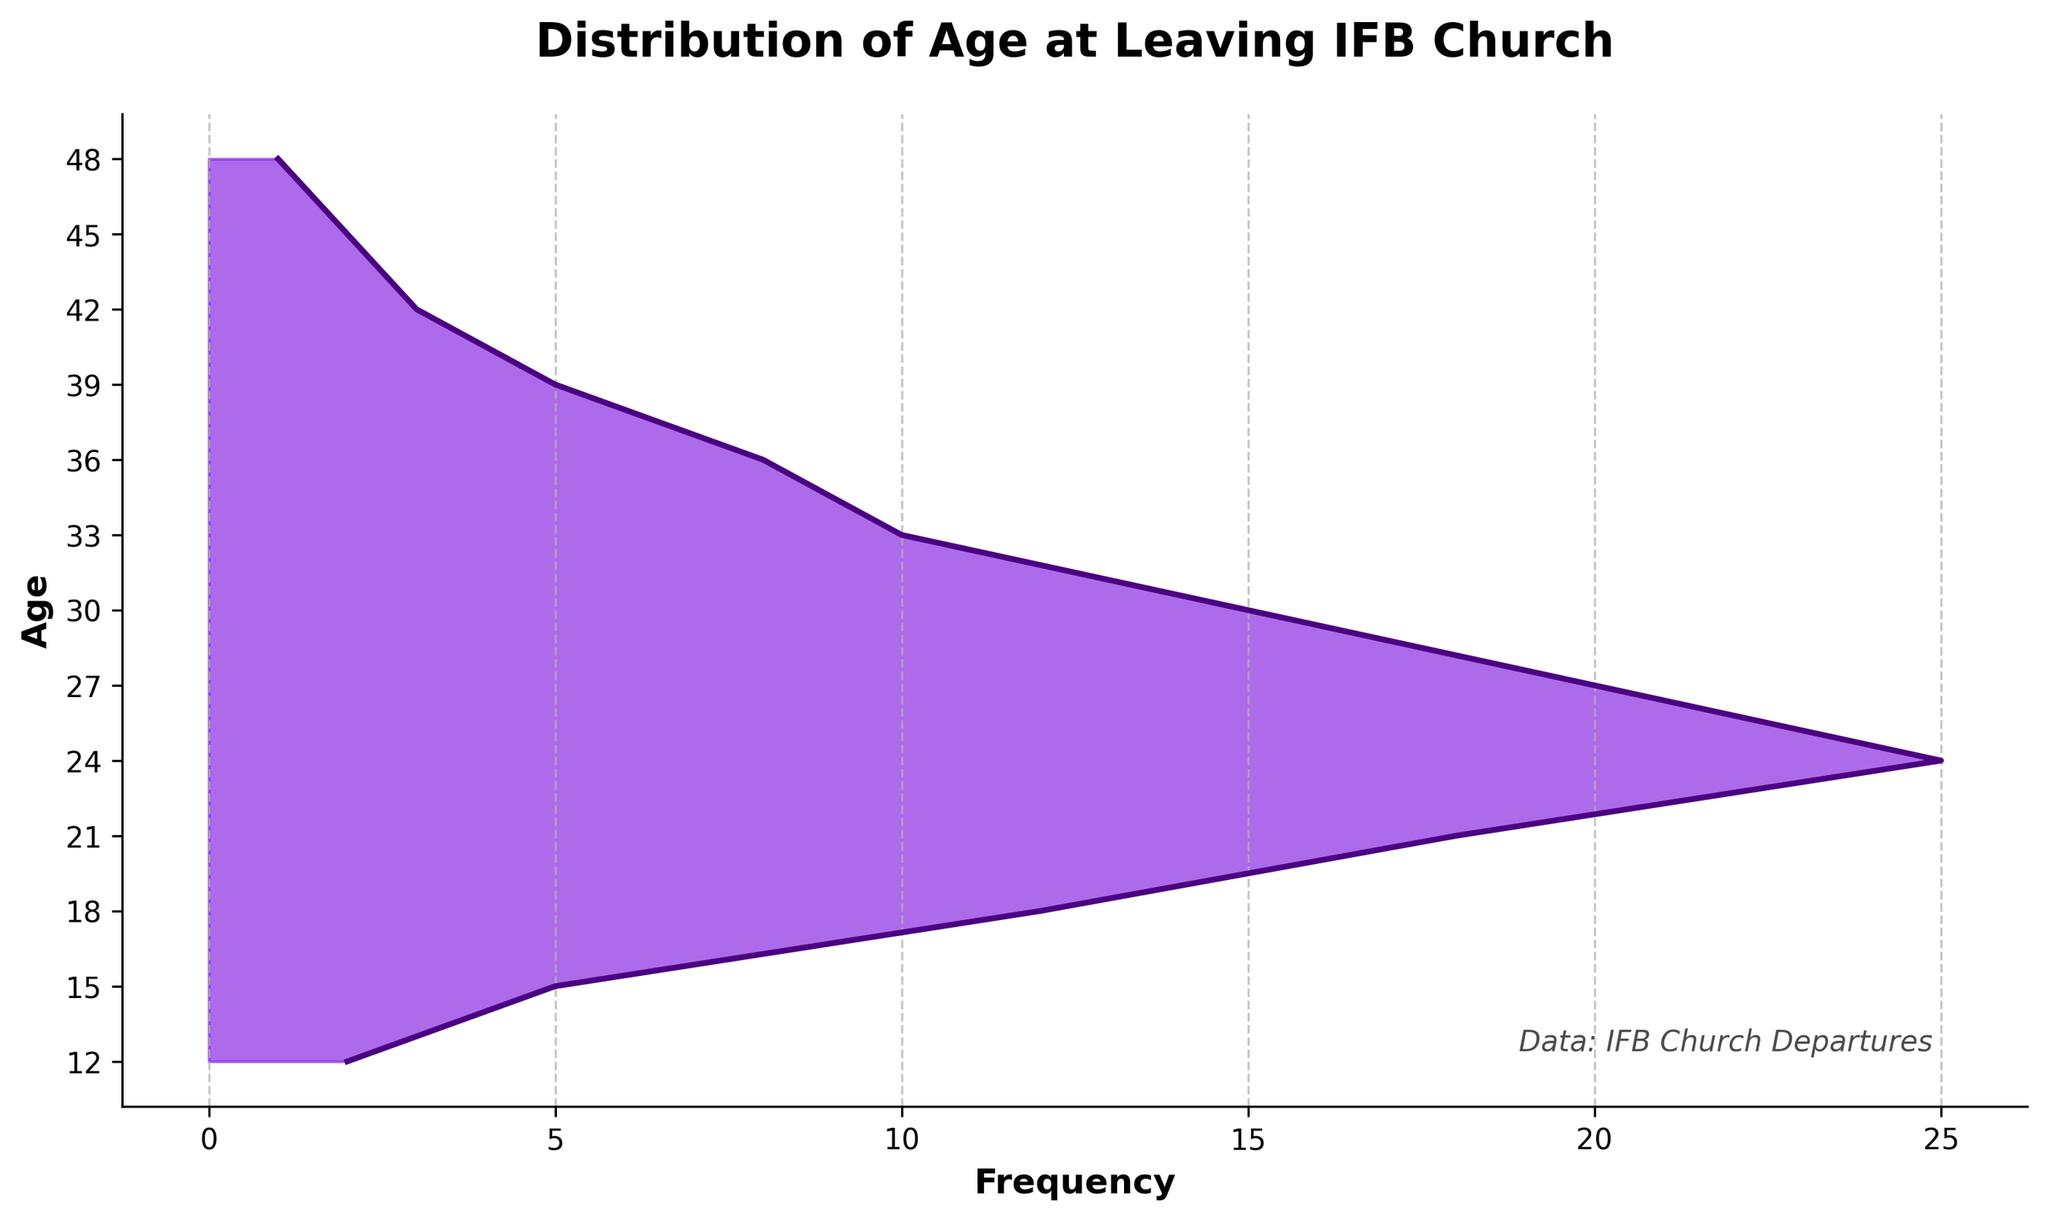What is the title of the plot? The title of the plot is displayed at the top in a larger and bold font. It reads 'Distribution of Age at Leaving IFB Church'.
Answer: Distribution of Age at Leaving IFB Church How many age groups are represented in the plot? The y-axis, labeled with ages, shows different age groups. By counting the labeled ages, we see there are 13 different age groups shown.
Answer: 13 Which age group has the highest frequency of leaving the IFB Church? The peak of the density plot indicates the highest frequency. Observing the plot, the highest frequency area corresponds to the age group at 24.
Answer: 24 At what two ages are the frequencies the same, other than the peak area? By observing the density plot, the frequencies at ages 15 and 39 appear to have the same height, indicating equal frequency.
Answer: 15 and 39 What is the overall shape of the distribution in the density plot? The density plot starts low at younger ages, increases to a peak around mid-twenties, and then gradually declines. This indicates a unimodal distribution with a peak at age 24.
Answer: Unimodal What is the frequency for the age group 33 in the plot? The point on the plot directly across from age 33 shows the corresponding frequency value, which is 10.
Answer: 10 Between which two ages does the largest increase in frequency occur? Analyzing the plot, we can see the largest increase in frequency occurs between ages 15 and 18.
Answer: 15 and 18 Around what age do most people leave the IFB Church based on the plot? The highest point of the plot, which indicates the mode, is around age 24. Thus, most people leave around this age.
Answer: 24 Compare the frequencies between ages 27 and 36. Which one is higher? Examining the heights on the plot for both ages, the frequency at age 27 is higher than that at age 36.
Answer: Age 27 What does the frequency trend look like from age 30 to age 45? The trend from age 30 to 45 shows a declining pattern in frequency. This indicates that fewer people leave the IFB Church as age increases beyond 30.
Answer: Declining 